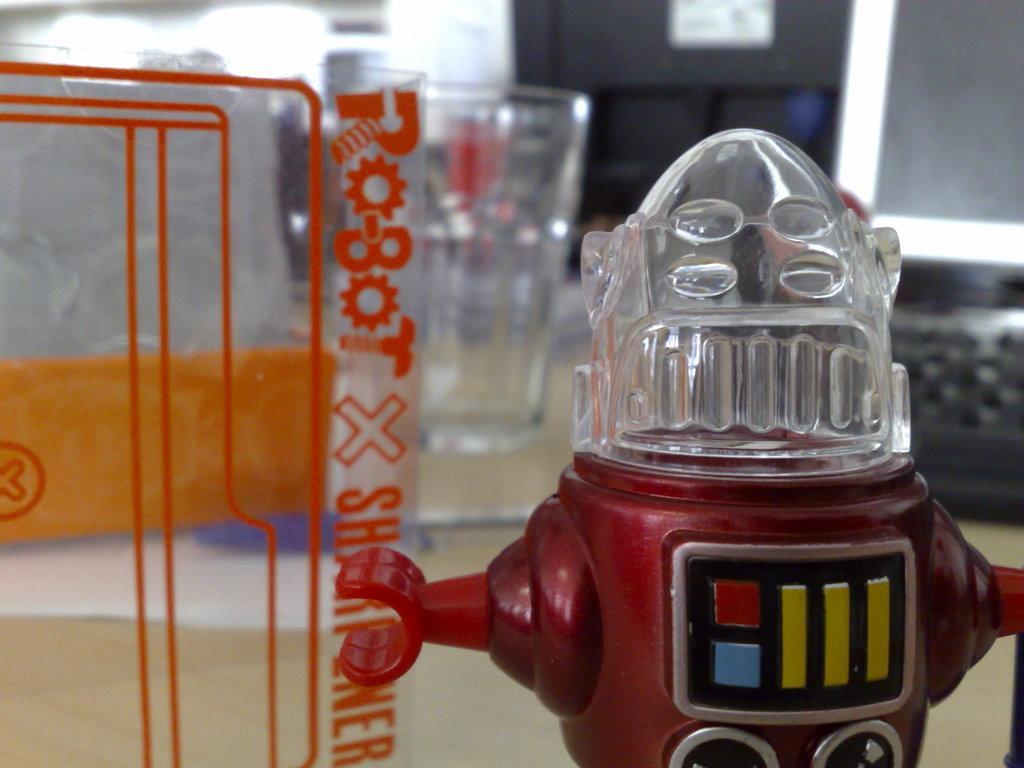<image>
Share a concise interpretation of the image provided. A small plastic robot toy on top of a table holding a sign with the word robot on it with the letters shaped as tools. 